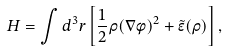<formula> <loc_0><loc_0><loc_500><loc_500>H = \int d ^ { 3 } r \left [ \frac { 1 } { 2 } \rho ( \nabla \phi ) ^ { 2 } + \tilde { \epsilon } ( \rho ) \right ] ,</formula> 